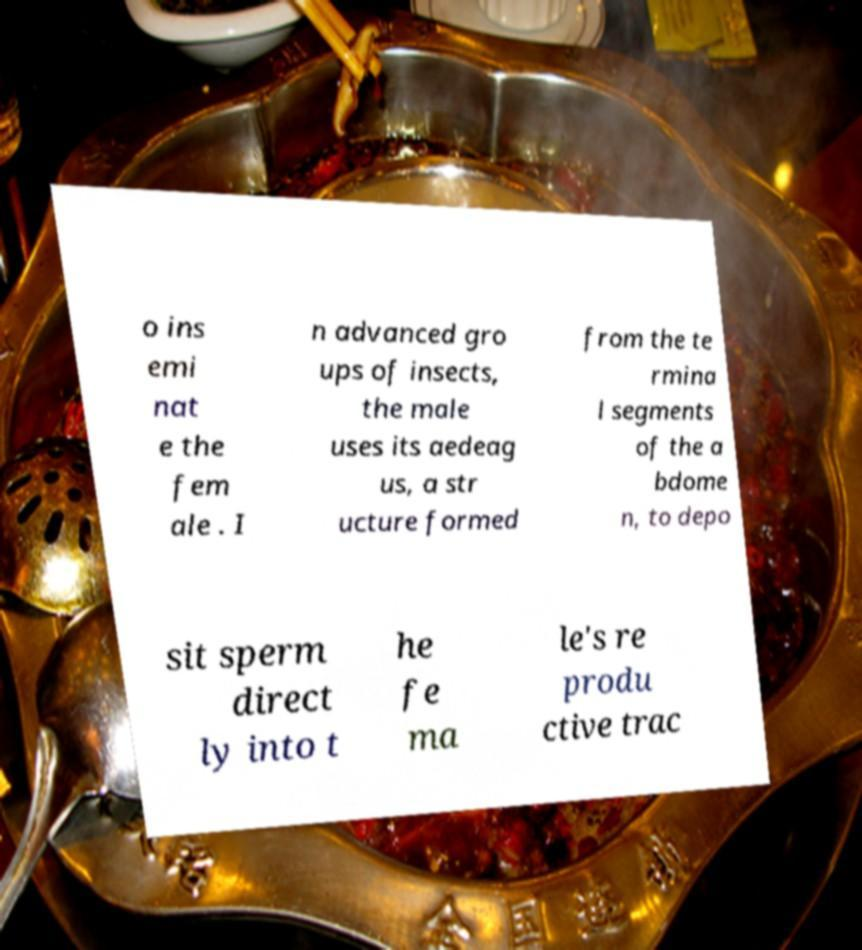Can you accurately transcribe the text from the provided image for me? o ins emi nat e the fem ale . I n advanced gro ups of insects, the male uses its aedeag us, a str ucture formed from the te rmina l segments of the a bdome n, to depo sit sperm direct ly into t he fe ma le's re produ ctive trac 